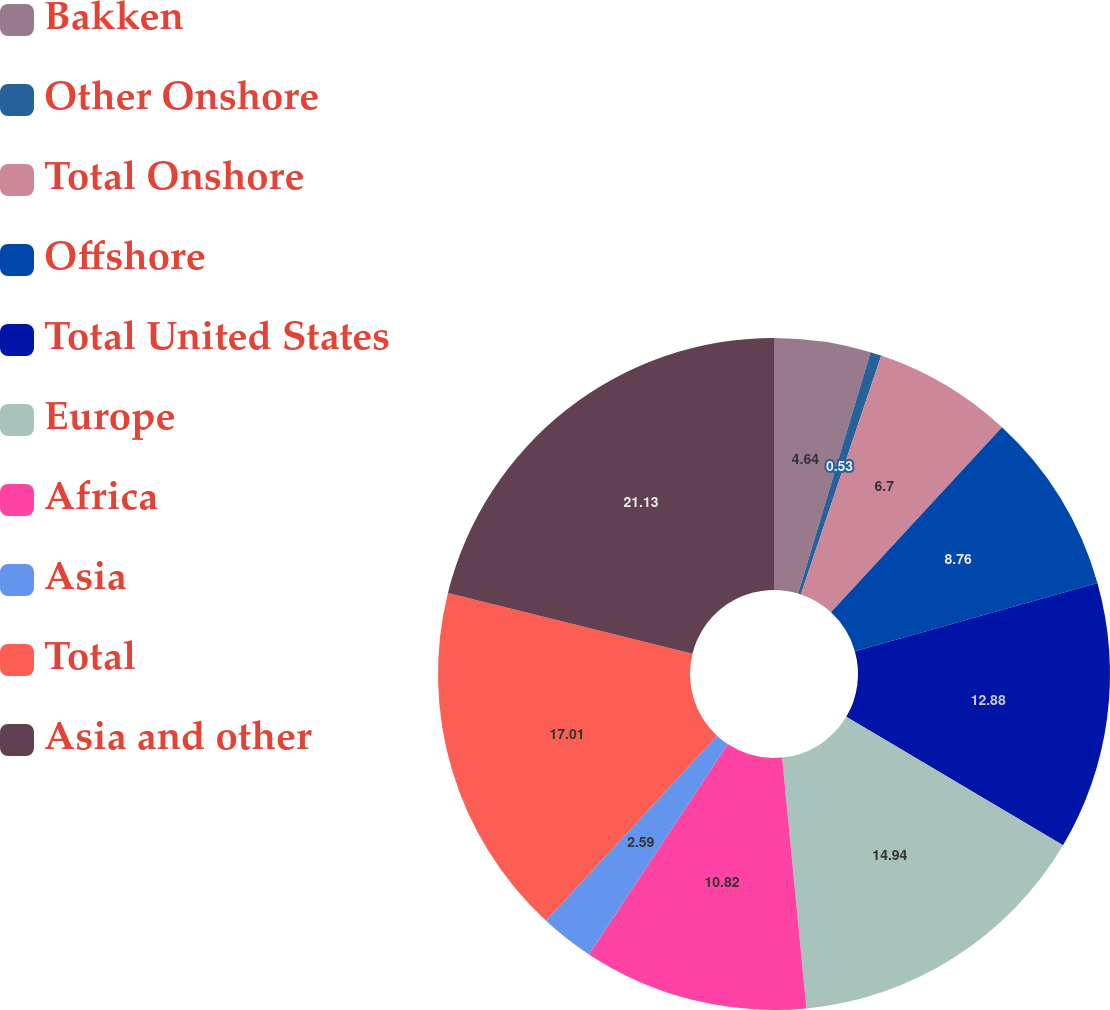<chart> <loc_0><loc_0><loc_500><loc_500><pie_chart><fcel>Bakken<fcel>Other Onshore<fcel>Total Onshore<fcel>Offshore<fcel>Total United States<fcel>Europe<fcel>Africa<fcel>Asia<fcel>Total<fcel>Asia and other<nl><fcel>4.64%<fcel>0.53%<fcel>6.7%<fcel>8.76%<fcel>12.88%<fcel>14.94%<fcel>10.82%<fcel>2.59%<fcel>17.0%<fcel>21.12%<nl></chart> 